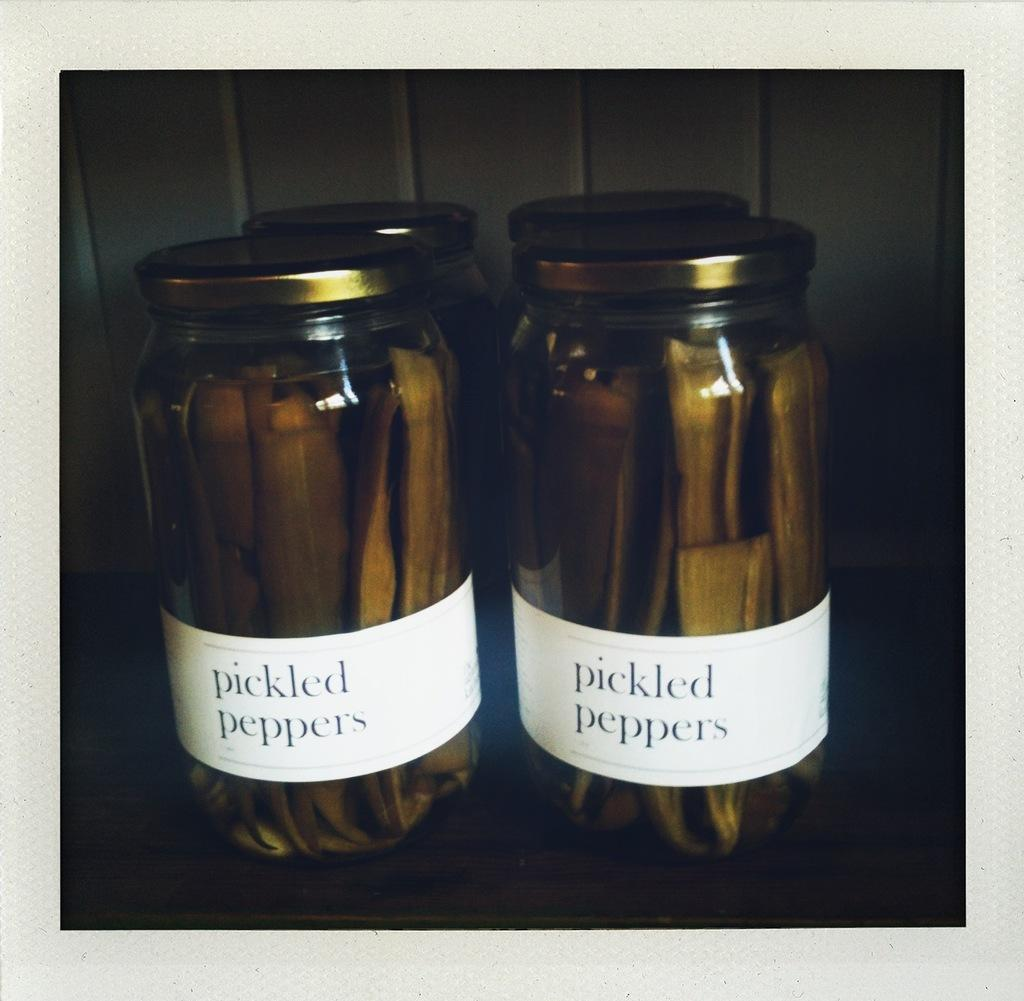<image>
Present a compact description of the photo's key features. Two jars with gold lids filled with pickled peppers. 